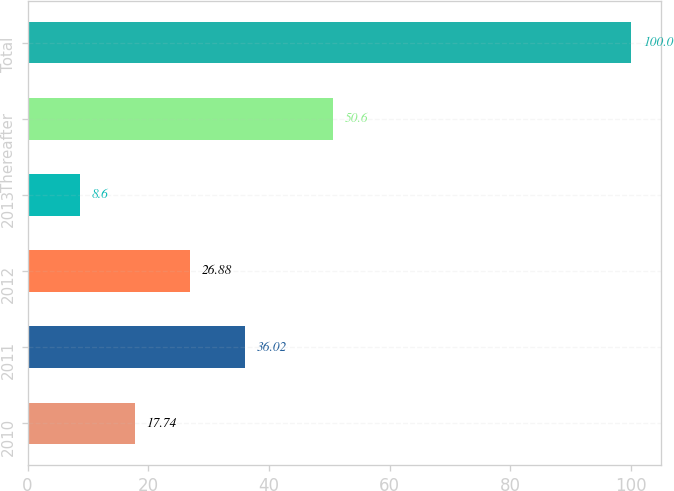Convert chart to OTSL. <chart><loc_0><loc_0><loc_500><loc_500><bar_chart><fcel>2010<fcel>2011<fcel>2012<fcel>2013<fcel>Thereafter<fcel>Total<nl><fcel>17.74<fcel>36.02<fcel>26.88<fcel>8.6<fcel>50.6<fcel>100<nl></chart> 